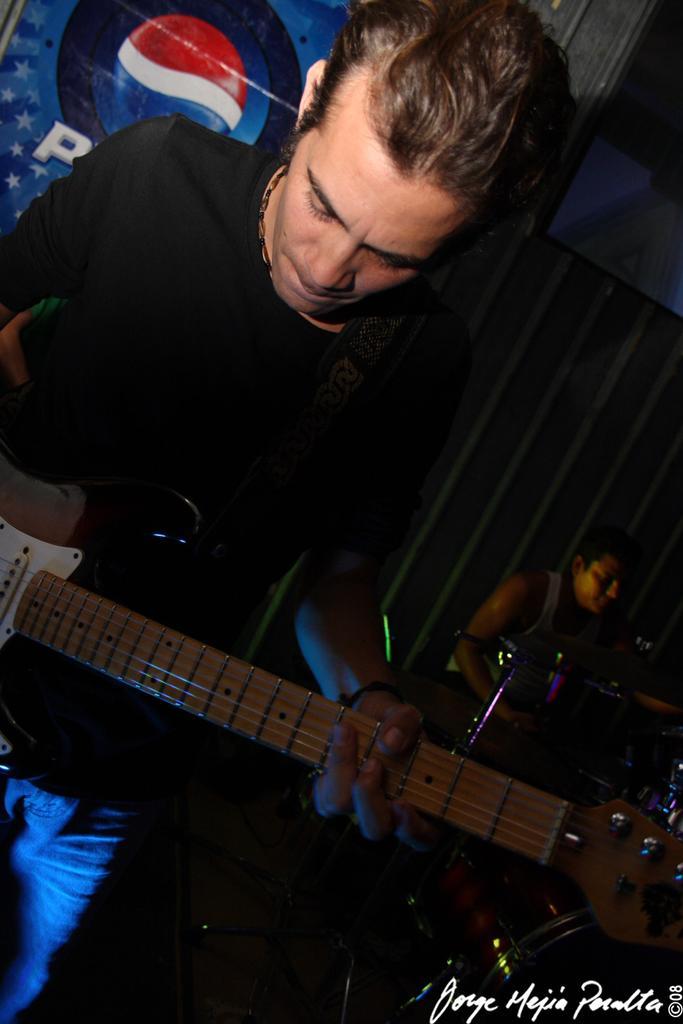Could you give a brief overview of what you see in this image? There is a man in the given picture, holding a guitar in his hand. In the background, there are some people playing some musical instrument here. 